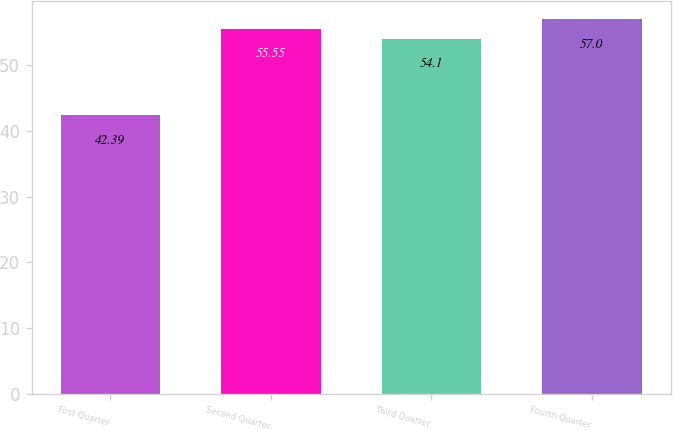Convert chart. <chart><loc_0><loc_0><loc_500><loc_500><bar_chart><fcel>First Quarter<fcel>Second Quarter<fcel>Third Quarter<fcel>Fourth Quarter<nl><fcel>42.39<fcel>55.55<fcel>54.1<fcel>57<nl></chart> 